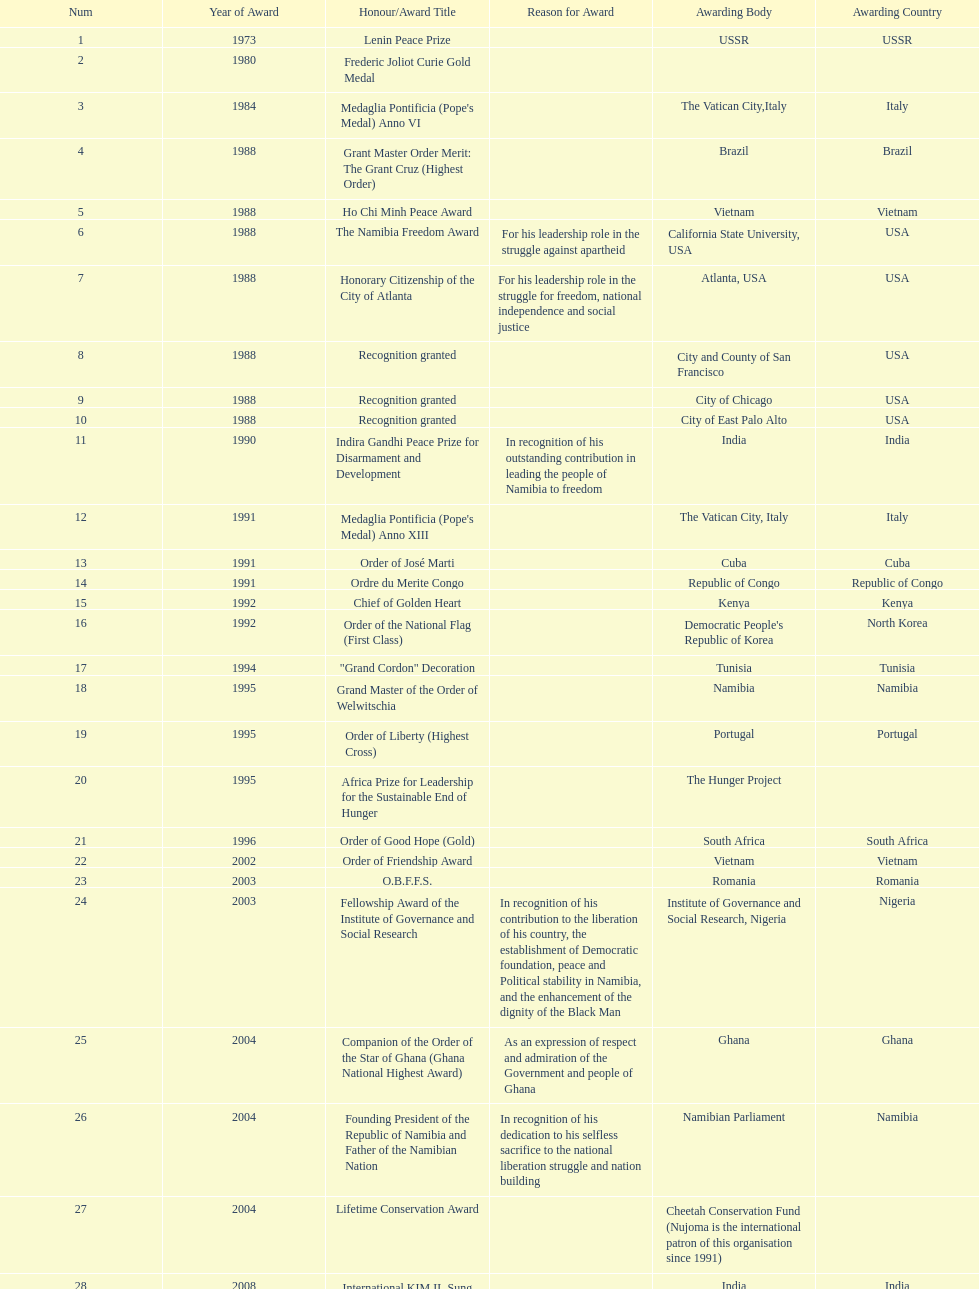The number of times "recognition granted" was the received award? 3. 